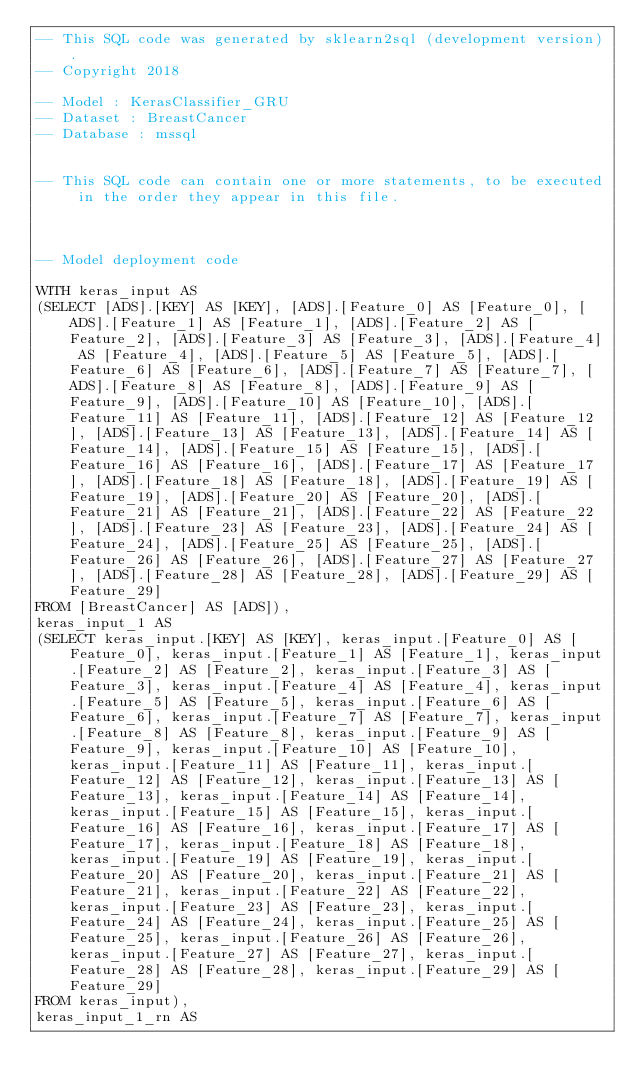Convert code to text. <code><loc_0><loc_0><loc_500><loc_500><_SQL_>-- This SQL code was generated by sklearn2sql (development version).
-- Copyright 2018

-- Model : KerasClassifier_GRU
-- Dataset : BreastCancer
-- Database : mssql


-- This SQL code can contain one or more statements, to be executed in the order they appear in this file.



-- Model deployment code

WITH keras_input AS 
(SELECT [ADS].[KEY] AS [KEY], [ADS].[Feature_0] AS [Feature_0], [ADS].[Feature_1] AS [Feature_1], [ADS].[Feature_2] AS [Feature_2], [ADS].[Feature_3] AS [Feature_3], [ADS].[Feature_4] AS [Feature_4], [ADS].[Feature_5] AS [Feature_5], [ADS].[Feature_6] AS [Feature_6], [ADS].[Feature_7] AS [Feature_7], [ADS].[Feature_8] AS [Feature_8], [ADS].[Feature_9] AS [Feature_9], [ADS].[Feature_10] AS [Feature_10], [ADS].[Feature_11] AS [Feature_11], [ADS].[Feature_12] AS [Feature_12], [ADS].[Feature_13] AS [Feature_13], [ADS].[Feature_14] AS [Feature_14], [ADS].[Feature_15] AS [Feature_15], [ADS].[Feature_16] AS [Feature_16], [ADS].[Feature_17] AS [Feature_17], [ADS].[Feature_18] AS [Feature_18], [ADS].[Feature_19] AS [Feature_19], [ADS].[Feature_20] AS [Feature_20], [ADS].[Feature_21] AS [Feature_21], [ADS].[Feature_22] AS [Feature_22], [ADS].[Feature_23] AS [Feature_23], [ADS].[Feature_24] AS [Feature_24], [ADS].[Feature_25] AS [Feature_25], [ADS].[Feature_26] AS [Feature_26], [ADS].[Feature_27] AS [Feature_27], [ADS].[Feature_28] AS [Feature_28], [ADS].[Feature_29] AS [Feature_29] 
FROM [BreastCancer] AS [ADS]), 
keras_input_1 AS 
(SELECT keras_input.[KEY] AS [KEY], keras_input.[Feature_0] AS [Feature_0], keras_input.[Feature_1] AS [Feature_1], keras_input.[Feature_2] AS [Feature_2], keras_input.[Feature_3] AS [Feature_3], keras_input.[Feature_4] AS [Feature_4], keras_input.[Feature_5] AS [Feature_5], keras_input.[Feature_6] AS [Feature_6], keras_input.[Feature_7] AS [Feature_7], keras_input.[Feature_8] AS [Feature_8], keras_input.[Feature_9] AS [Feature_9], keras_input.[Feature_10] AS [Feature_10], keras_input.[Feature_11] AS [Feature_11], keras_input.[Feature_12] AS [Feature_12], keras_input.[Feature_13] AS [Feature_13], keras_input.[Feature_14] AS [Feature_14], keras_input.[Feature_15] AS [Feature_15], keras_input.[Feature_16] AS [Feature_16], keras_input.[Feature_17] AS [Feature_17], keras_input.[Feature_18] AS [Feature_18], keras_input.[Feature_19] AS [Feature_19], keras_input.[Feature_20] AS [Feature_20], keras_input.[Feature_21] AS [Feature_21], keras_input.[Feature_22] AS [Feature_22], keras_input.[Feature_23] AS [Feature_23], keras_input.[Feature_24] AS [Feature_24], keras_input.[Feature_25] AS [Feature_25], keras_input.[Feature_26] AS [Feature_26], keras_input.[Feature_27] AS [Feature_27], keras_input.[Feature_28] AS [Feature_28], keras_input.[Feature_29] AS [Feature_29] 
FROM keras_input), 
keras_input_1_rn AS </code> 